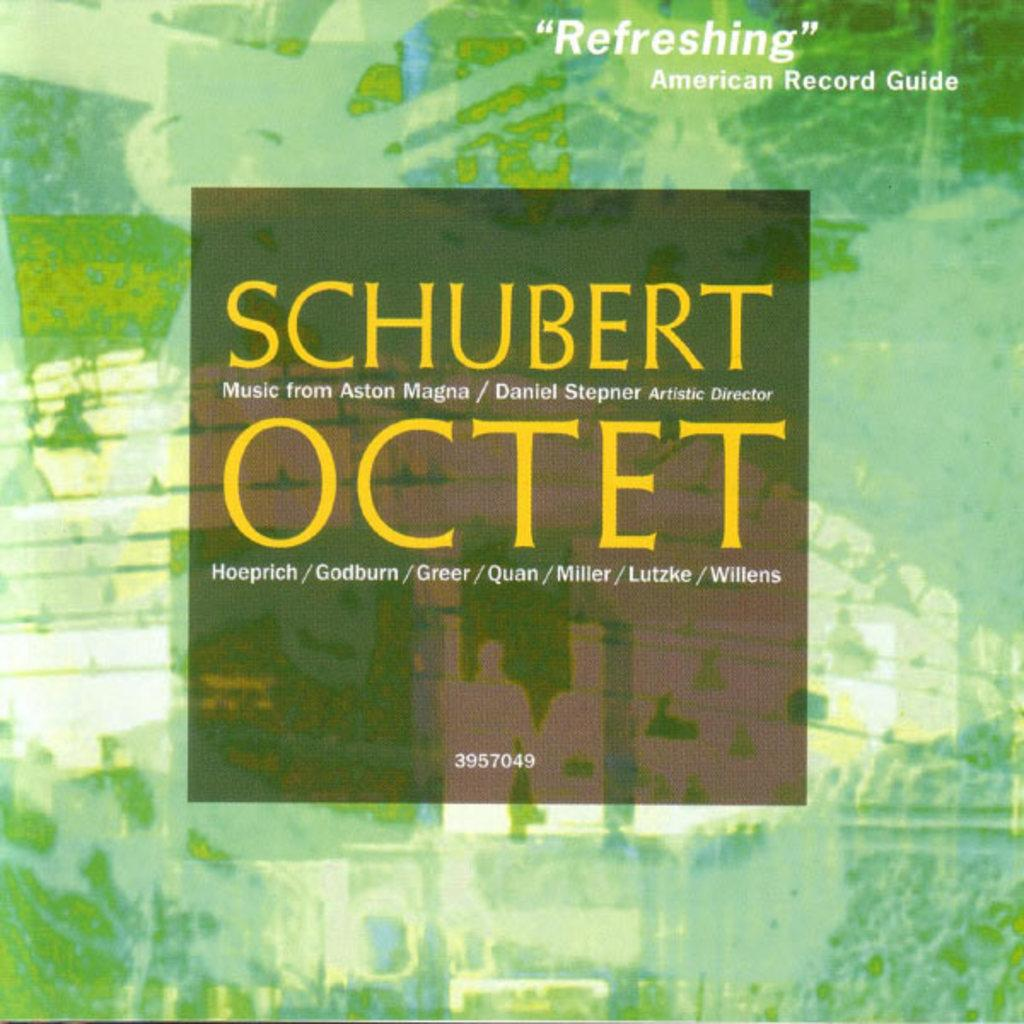<image>
Summarize the visual content of the image. The cover of a Schubert recording performed by an octet. 